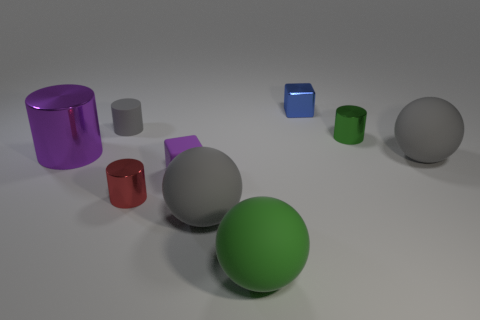How many objects are there in the image, and can you describe their colors and shapes? There are seven objects in the image. Starting from the left, there's a purple cylinder, a small gray cube, a red cylinder, a large gray sphere, a green cube, a large green sphere, and lastly, a gray sphere on the far right. 